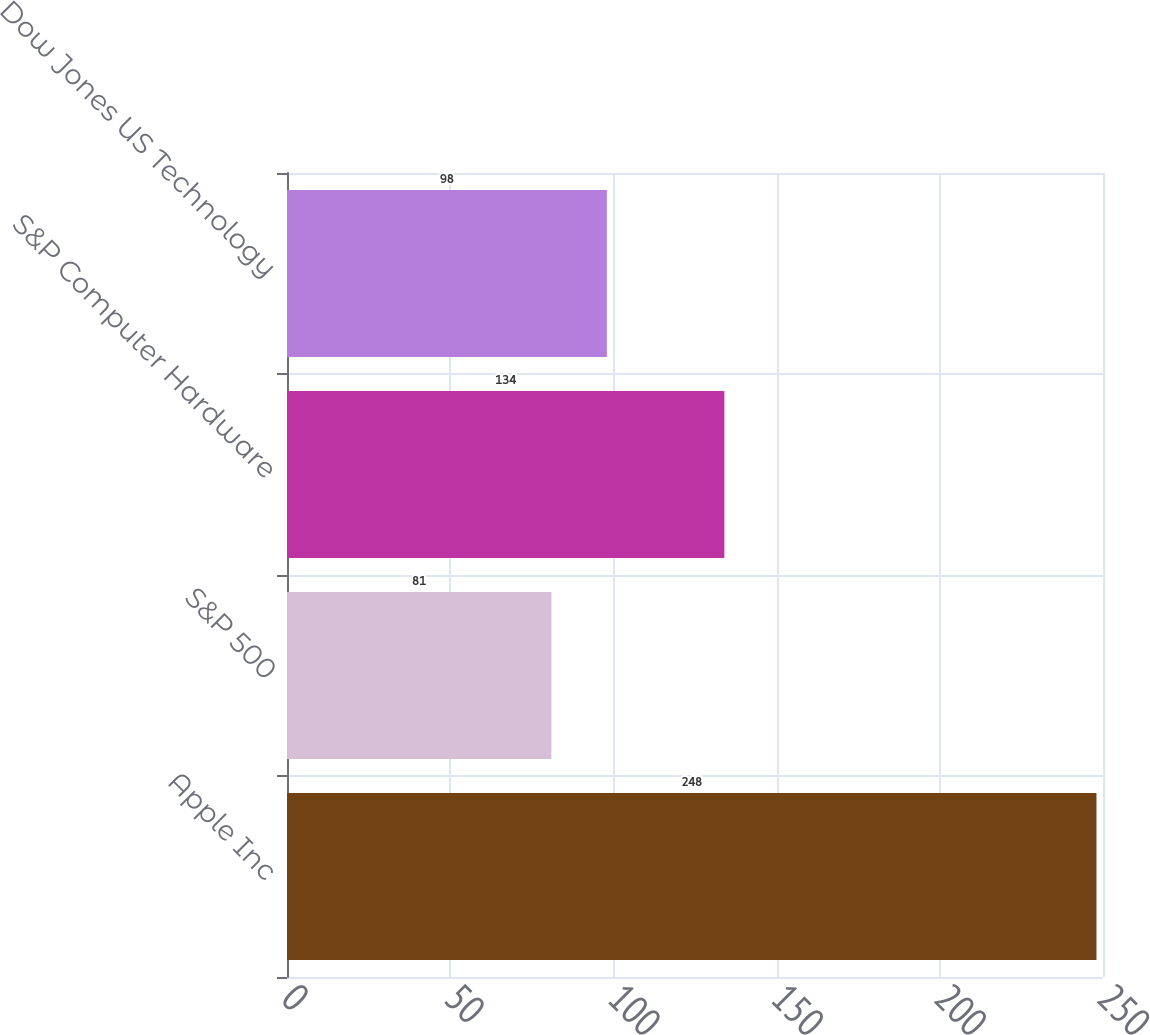Convert chart. <chart><loc_0><loc_0><loc_500><loc_500><bar_chart><fcel>Apple Inc<fcel>S&P 500<fcel>S&P Computer Hardware<fcel>Dow Jones US Technology<nl><fcel>248<fcel>81<fcel>134<fcel>98<nl></chart> 